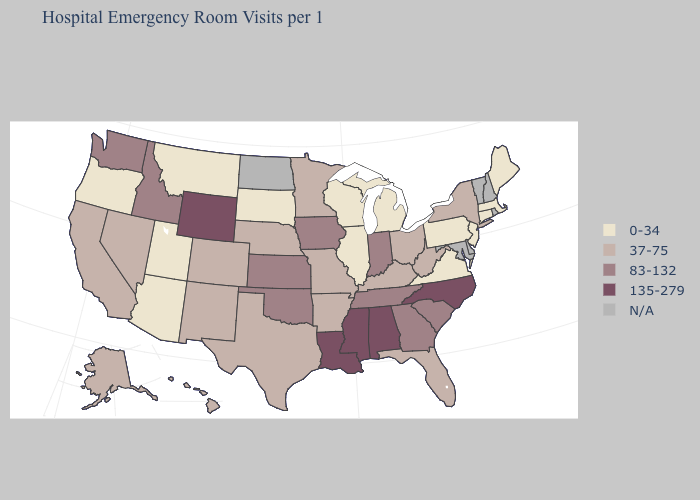What is the value of Pennsylvania?
Give a very brief answer. 0-34. Which states hav the highest value in the MidWest?
Quick response, please. Indiana, Iowa, Kansas. What is the highest value in the West ?
Be succinct. 135-279. Among the states that border Connecticut , which have the lowest value?
Quick response, please. Massachusetts. Name the states that have a value in the range 135-279?
Answer briefly. Alabama, Louisiana, Mississippi, North Carolina, Wyoming. What is the value of Wyoming?
Quick response, please. 135-279. Name the states that have a value in the range 135-279?
Answer briefly. Alabama, Louisiana, Mississippi, North Carolina, Wyoming. What is the value of Minnesota?
Quick response, please. 37-75. What is the value of California?
Concise answer only. 37-75. Which states have the lowest value in the West?
Write a very short answer. Arizona, Montana, Oregon, Utah. Which states have the highest value in the USA?
Concise answer only. Alabama, Louisiana, Mississippi, North Carolina, Wyoming. Among the states that border Virginia , does West Virginia have the lowest value?
Quick response, please. Yes. 